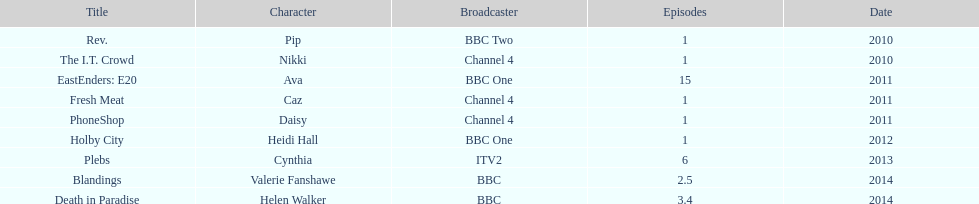What is the sum of shows featuring sophie colguhoun? 9. 